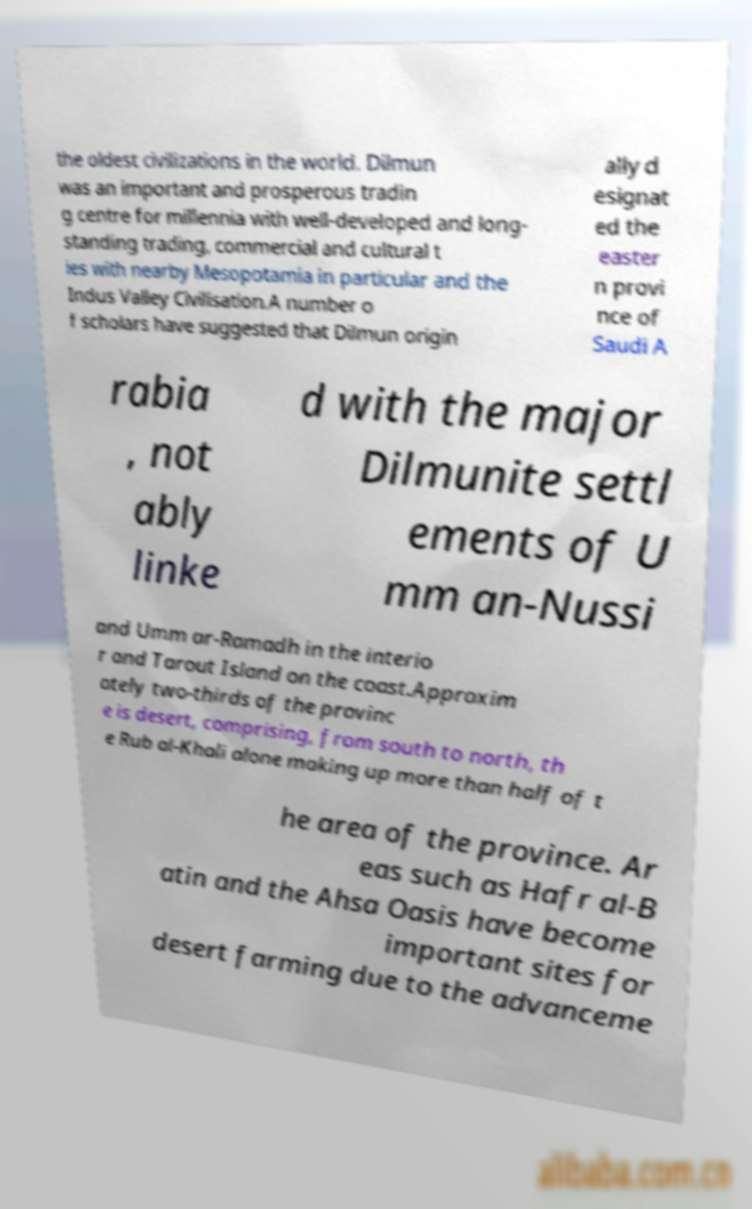Can you accurately transcribe the text from the provided image for me? the oldest civilizations in the world. Dilmun was an important and prosperous tradin g centre for millennia with well-developed and long- standing trading, commercial and cultural t ies with nearby Mesopotamia in particular and the Indus Valley Civilisation.A number o f scholars have suggested that Dilmun origin ally d esignat ed the easter n provi nce of Saudi A rabia , not ably linke d with the major Dilmunite settl ements of U mm an-Nussi and Umm ar-Ramadh in the interio r and Tarout Island on the coast.Approxim ately two-thirds of the provinc e is desert, comprising, from south to north, th e Rub al-Khali alone making up more than half of t he area of the province. Ar eas such as Hafr al-B atin and the Ahsa Oasis have become important sites for desert farming due to the advanceme 